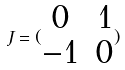Convert formula to latex. <formula><loc_0><loc_0><loc_500><loc_500>J = ( \begin{matrix} 0 & 1 \\ - 1 & 0 \end{matrix} )</formula> 